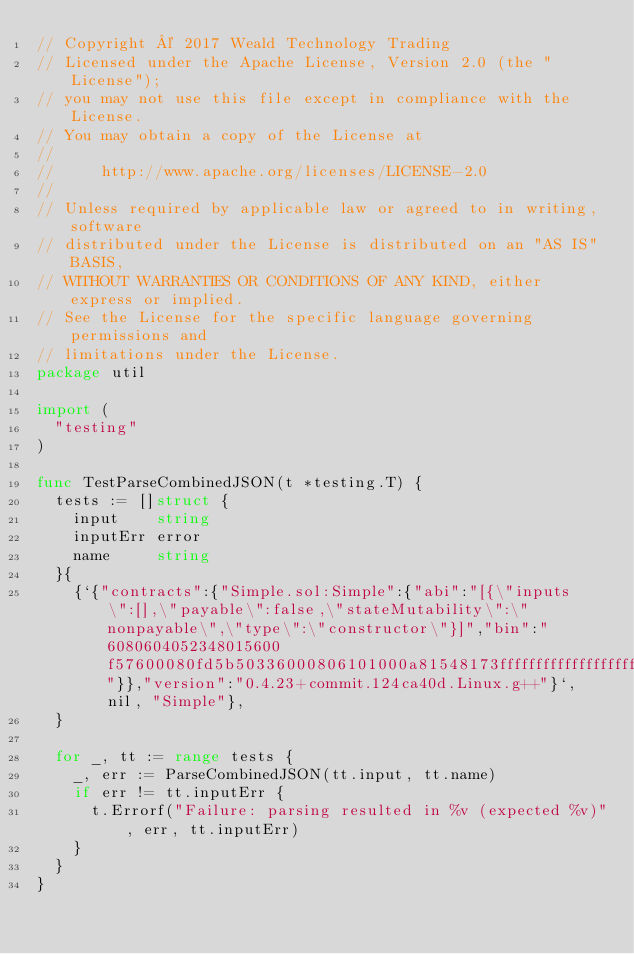<code> <loc_0><loc_0><loc_500><loc_500><_Go_>// Copyright © 2017 Weald Technology Trading
// Licensed under the Apache License, Version 2.0 (the "License");
// you may not use this file except in compliance with the License.
// You may obtain a copy of the License at
//
//     http://www.apache.org/licenses/LICENSE-2.0
//
// Unless required by applicable law or agreed to in writing, software
// distributed under the License is distributed on an "AS IS" BASIS,
// WITHOUT WARRANTIES OR CONDITIONS OF ANY KIND, either express or implied.
// See the License for the specific language governing permissions and
// limitations under the License.
package util

import (
	"testing"
)

func TestParseCombinedJSON(t *testing.T) {
	tests := []struct {
		input    string
		inputErr error
		name     string
	}{
		{`{"contracts":{"Simple.sol:Simple":{"abi":"[{\"inputs\":[],\"payable\":false,\"stateMutability\":\"nonpayable\",\"type\":\"constructor\"}]","bin":"6080604052348015600f57600080fd5b50336000806101000a81548173ffffffffffffffffffffffffffffffffffffffff021916908373ffffffffffffffffffffffffffffffffffffffff160217905550603580605d6000396000f3006080604052600080fd00a165627a7a7230582083d530c10e079e85c2f5030dc4ff81c9c24ad62d6af39470de661d4596b5766e0029"}},"version":"0.4.23+commit.124ca40d.Linux.g++"}`, nil, "Simple"},
	}

	for _, tt := range tests {
		_, err := ParseCombinedJSON(tt.input, tt.name)
		if err != tt.inputErr {
			t.Errorf("Failure: parsing resulted in %v (expected %v)", err, tt.inputErr)
		}
	}
}
</code> 